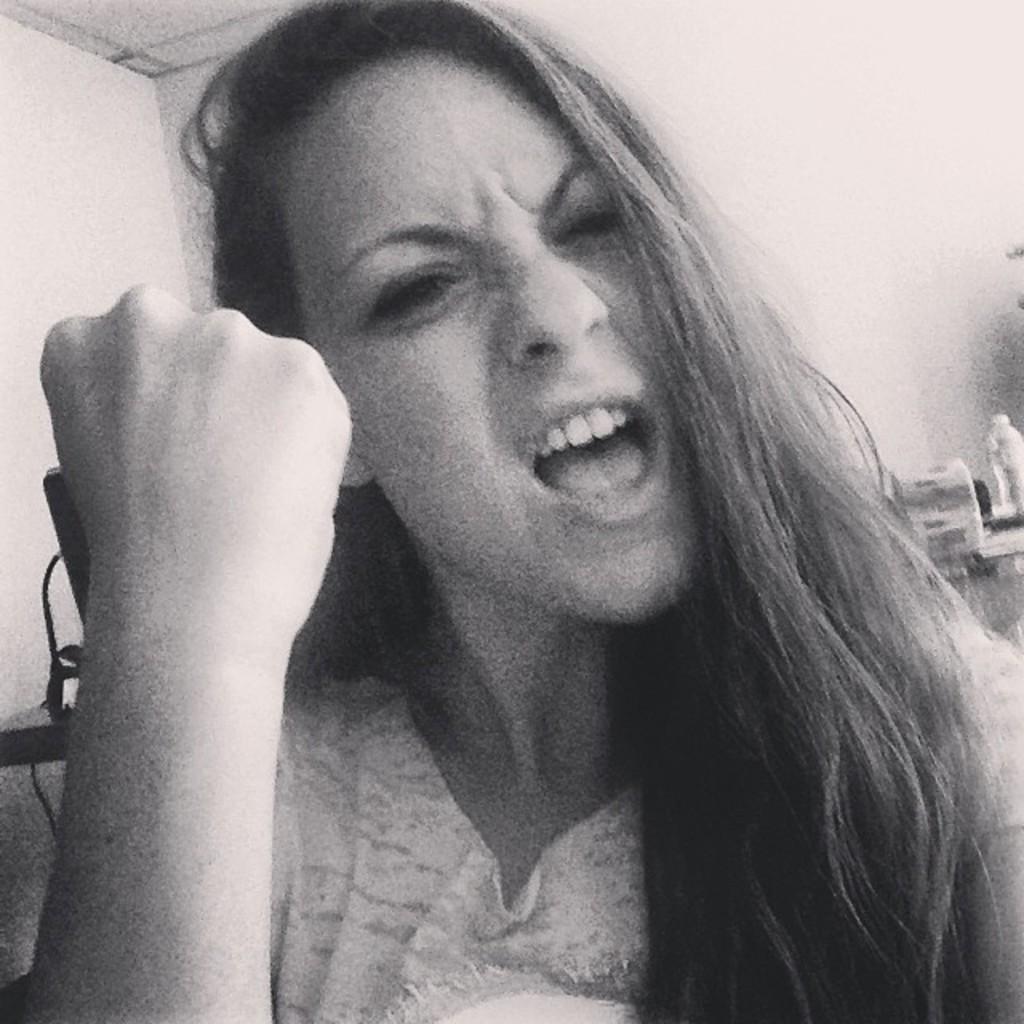Describe this image in one or two sentences. There is a woman opened her mouth and shaking her fist and there are some other objects behind her. 